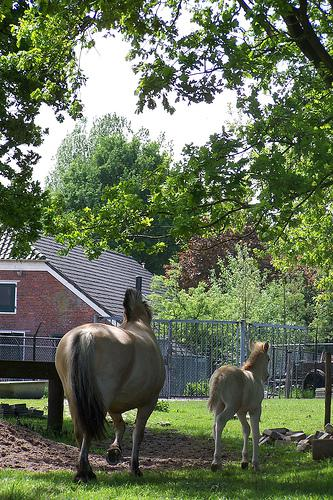Question: what kind of animal is in the picture?
Choices:
A. Horse.
B. Sheep.
C. Cow.
D. Donkey.
Answer with the letter. Answer: A Question: how many horses are in the picture?
Choices:
A. Three.
B. Four.
C. Two.
D. Five.
Answer with the letter. Answer: C Question: what color is the large horse?
Choices:
A. Brown.
B. Black.
C. Gray.
D. White.
Answer with the letter. Answer: A Question: where are the horses?
Choices:
A. On the beach.
B. At the track.
C. In the stable.
D. On the grass.
Answer with the letter. Answer: D Question: what color is the grass?
Choices:
A. Brown.
B. Green.
C. Orange.
D. Mint.
Answer with the letter. Answer: B 